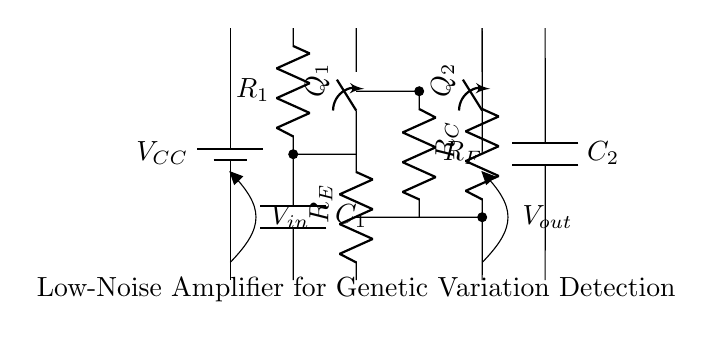What type of amplifier is represented in this circuit? The circuit is identified as a low-noise amplifier, which is typically used to amplify small signals with minimal added noise. This is evident from the description label in the diagram.
Answer: low-noise amplifier What is the role of the capacitor C1? Capacitor C1 is used for coupling, which helps in blocking DC while allowing AC signals to pass through. This is important to prevent DC biasing of the input signal and maintain signal integrity.
Answer: coupling Which components are responsible for the feedback in the circuit? The feedback network consists of the resistor R_F connected from the output stage to the input, providing negative feedback to stabilize and improve the gain of the amplifier.
Answer: R_F How does the output voltage relate to the input voltage? The output voltage, V_out, is determined by the gain of the amplifier, which factors in the input voltage, gain settings, and the resistance values used in the feedback and input stages. This relationship is essential for understanding the amplification effect.
Answer: gain relation What is the purpose of the decoupling capacitor C2? Decoupling capacitor C2 is used to filter out high-frequency noise from the power supply, thereby stabilizing the voltage supply and improving the overall performance of the amplifier circuit.
Answer: filter high-frequency noise Which transistor is likely responsible for the initial signal amplification? The transistor Q_1 is positioned at the input stage of the circuit, indicating that it is the first point of signal amplification in this configuration. This positioning is typical for amplifying weak signals before they are processed further.
Answer: Q_1 